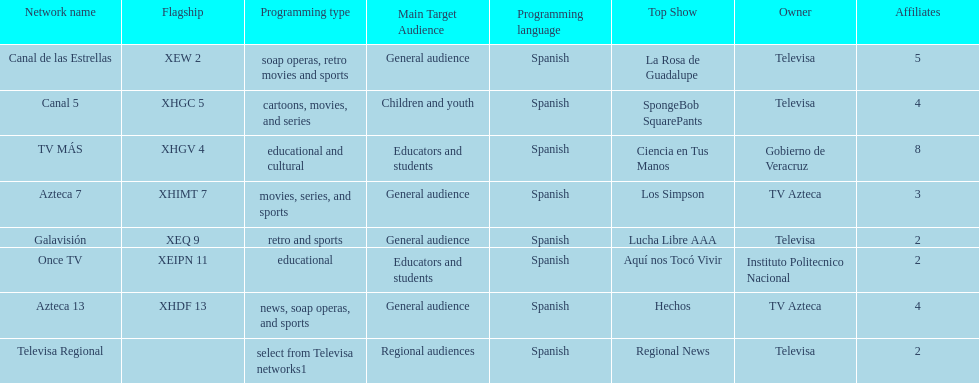How many networks show soap operas? 2. 